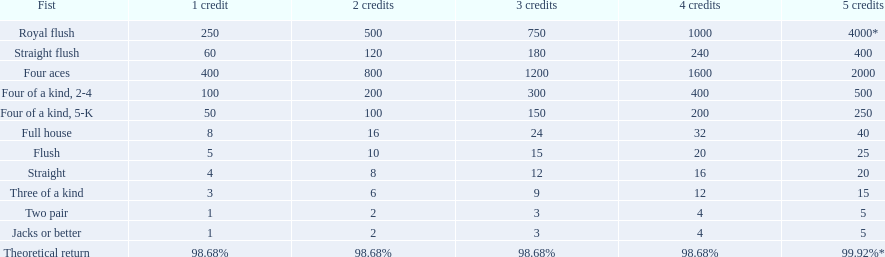What are each of the hands? Royal flush, Straight flush, Four aces, Four of a kind, 2-4, Four of a kind, 5-K, Full house, Flush, Straight, Three of a kind, Two pair, Jacks or better, Theoretical return. Which hand ranks higher between straights and flushes? Flush. 